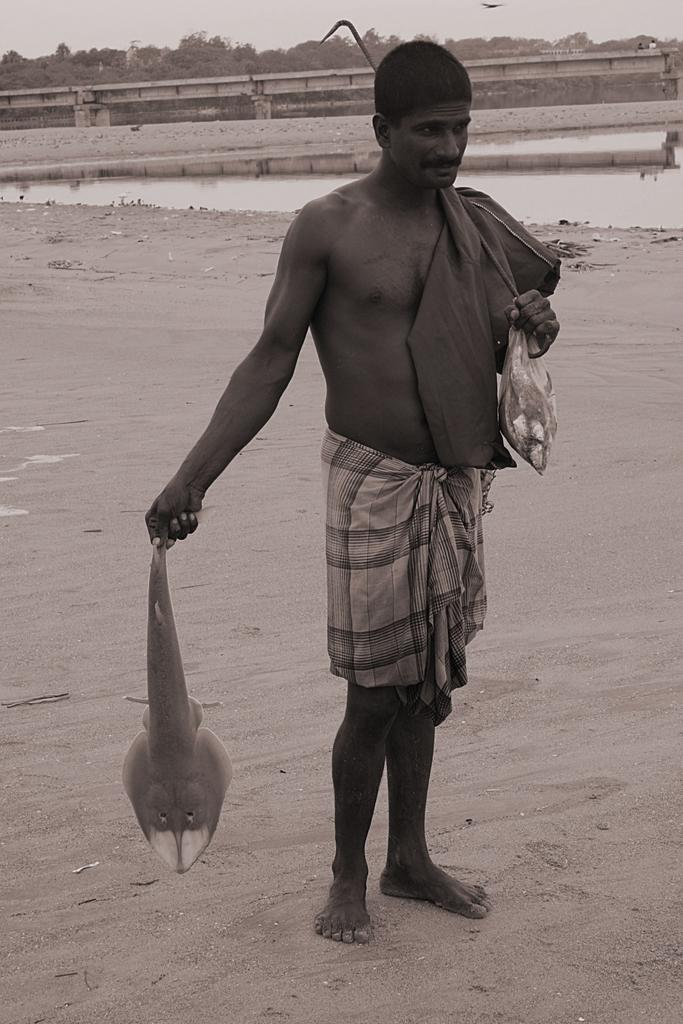What is the person in the image holding? The person is holding fishes and sticks in the image. Where is the person standing? The person is standing on the floor in the image. What can be seen in the background of the image? There is a lake, a bridge, trees, and the sky visible in the background of the image. What type of sink can be seen in the image? There is no sink present in the image. Who gave their approval for the person to hold the fishes and sticks in the image? There is no indication in the image that someone gave their approval for the person to hold the fishes and sticks. 